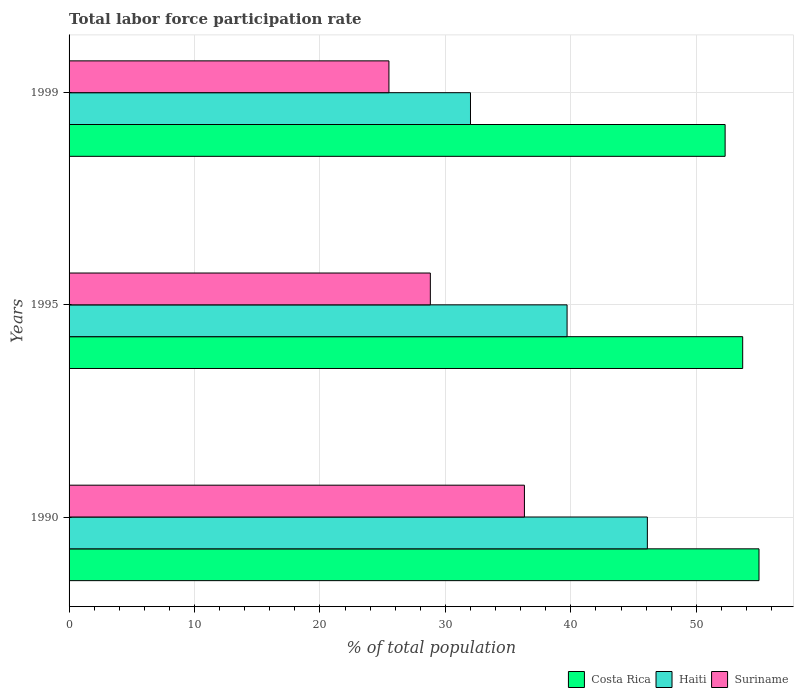How many bars are there on the 2nd tick from the top?
Make the answer very short. 3. In how many cases, is the number of bars for a given year not equal to the number of legend labels?
Your answer should be very brief. 0. What is the total labor force participation rate in Suriname in 1995?
Make the answer very short. 28.8. Across all years, what is the maximum total labor force participation rate in Costa Rica?
Your answer should be very brief. 55. In which year was the total labor force participation rate in Suriname minimum?
Ensure brevity in your answer.  1999. What is the total total labor force participation rate in Haiti in the graph?
Provide a succinct answer. 117.8. What is the difference between the total labor force participation rate in Suriname in 1990 and that in 1995?
Keep it short and to the point. 7.5. What is the difference between the total labor force participation rate in Haiti in 1990 and the total labor force participation rate in Suriname in 1995?
Your answer should be very brief. 17.3. What is the average total labor force participation rate in Haiti per year?
Offer a terse response. 39.27. In the year 1995, what is the difference between the total labor force participation rate in Haiti and total labor force participation rate in Costa Rica?
Provide a short and direct response. -14. What is the ratio of the total labor force participation rate in Haiti in 1990 to that in 1999?
Offer a terse response. 1.44. Is the difference between the total labor force participation rate in Haiti in 1990 and 1999 greater than the difference between the total labor force participation rate in Costa Rica in 1990 and 1999?
Ensure brevity in your answer.  Yes. What is the difference between the highest and the second highest total labor force participation rate in Costa Rica?
Provide a short and direct response. 1.3. What is the difference between the highest and the lowest total labor force participation rate in Haiti?
Offer a very short reply. 14.1. In how many years, is the total labor force participation rate in Suriname greater than the average total labor force participation rate in Suriname taken over all years?
Ensure brevity in your answer.  1. Is the sum of the total labor force participation rate in Costa Rica in 1990 and 1999 greater than the maximum total labor force participation rate in Suriname across all years?
Offer a terse response. Yes. What does the 1st bar from the top in 1995 represents?
Give a very brief answer. Suriname. What does the 3rd bar from the bottom in 1990 represents?
Your answer should be compact. Suriname. Is it the case that in every year, the sum of the total labor force participation rate in Suriname and total labor force participation rate in Haiti is greater than the total labor force participation rate in Costa Rica?
Ensure brevity in your answer.  Yes. How many bars are there?
Your answer should be compact. 9. Are all the bars in the graph horizontal?
Give a very brief answer. Yes. What is the difference between two consecutive major ticks on the X-axis?
Your answer should be very brief. 10. Are the values on the major ticks of X-axis written in scientific E-notation?
Provide a short and direct response. No. Does the graph contain any zero values?
Provide a succinct answer. No. Does the graph contain grids?
Make the answer very short. Yes. Where does the legend appear in the graph?
Ensure brevity in your answer.  Bottom right. How many legend labels are there?
Offer a terse response. 3. How are the legend labels stacked?
Give a very brief answer. Horizontal. What is the title of the graph?
Provide a succinct answer. Total labor force participation rate. Does "Canada" appear as one of the legend labels in the graph?
Give a very brief answer. No. What is the label or title of the X-axis?
Your answer should be compact. % of total population. What is the label or title of the Y-axis?
Make the answer very short. Years. What is the % of total population of Haiti in 1990?
Offer a terse response. 46.1. What is the % of total population in Suriname in 1990?
Ensure brevity in your answer.  36.3. What is the % of total population in Costa Rica in 1995?
Your answer should be compact. 53.7. What is the % of total population in Haiti in 1995?
Your response must be concise. 39.7. What is the % of total population in Suriname in 1995?
Your answer should be compact. 28.8. What is the % of total population in Costa Rica in 1999?
Give a very brief answer. 52.3. What is the % of total population in Haiti in 1999?
Offer a terse response. 32. Across all years, what is the maximum % of total population in Haiti?
Your answer should be compact. 46.1. Across all years, what is the maximum % of total population of Suriname?
Your answer should be compact. 36.3. Across all years, what is the minimum % of total population of Costa Rica?
Your answer should be very brief. 52.3. Across all years, what is the minimum % of total population of Haiti?
Your answer should be very brief. 32. Across all years, what is the minimum % of total population of Suriname?
Your answer should be compact. 25.5. What is the total % of total population in Costa Rica in the graph?
Make the answer very short. 161. What is the total % of total population in Haiti in the graph?
Give a very brief answer. 117.8. What is the total % of total population of Suriname in the graph?
Offer a very short reply. 90.6. What is the difference between the % of total population in Costa Rica in 1990 and that in 1995?
Your answer should be very brief. 1.3. What is the difference between the % of total population of Haiti in 1990 and that in 1999?
Give a very brief answer. 14.1. What is the difference between the % of total population of Costa Rica in 1990 and the % of total population of Haiti in 1995?
Your answer should be compact. 15.3. What is the difference between the % of total population of Costa Rica in 1990 and the % of total population of Suriname in 1995?
Provide a succinct answer. 26.2. What is the difference between the % of total population of Haiti in 1990 and the % of total population of Suriname in 1995?
Ensure brevity in your answer.  17.3. What is the difference between the % of total population of Costa Rica in 1990 and the % of total population of Haiti in 1999?
Offer a very short reply. 23. What is the difference between the % of total population in Costa Rica in 1990 and the % of total population in Suriname in 1999?
Your answer should be very brief. 29.5. What is the difference between the % of total population in Haiti in 1990 and the % of total population in Suriname in 1999?
Provide a short and direct response. 20.6. What is the difference between the % of total population in Costa Rica in 1995 and the % of total population in Haiti in 1999?
Give a very brief answer. 21.7. What is the difference between the % of total population of Costa Rica in 1995 and the % of total population of Suriname in 1999?
Offer a terse response. 28.2. What is the difference between the % of total population of Haiti in 1995 and the % of total population of Suriname in 1999?
Provide a short and direct response. 14.2. What is the average % of total population of Costa Rica per year?
Ensure brevity in your answer.  53.67. What is the average % of total population in Haiti per year?
Your response must be concise. 39.27. What is the average % of total population of Suriname per year?
Offer a very short reply. 30.2. In the year 1990, what is the difference between the % of total population of Costa Rica and % of total population of Suriname?
Offer a terse response. 18.7. In the year 1995, what is the difference between the % of total population of Costa Rica and % of total population of Haiti?
Provide a succinct answer. 14. In the year 1995, what is the difference between the % of total population of Costa Rica and % of total population of Suriname?
Your response must be concise. 24.9. In the year 1995, what is the difference between the % of total population in Haiti and % of total population in Suriname?
Give a very brief answer. 10.9. In the year 1999, what is the difference between the % of total population of Costa Rica and % of total population of Haiti?
Make the answer very short. 20.3. In the year 1999, what is the difference between the % of total population of Costa Rica and % of total population of Suriname?
Ensure brevity in your answer.  26.8. In the year 1999, what is the difference between the % of total population in Haiti and % of total population in Suriname?
Ensure brevity in your answer.  6.5. What is the ratio of the % of total population in Costa Rica in 1990 to that in 1995?
Your answer should be very brief. 1.02. What is the ratio of the % of total population in Haiti in 1990 to that in 1995?
Your response must be concise. 1.16. What is the ratio of the % of total population in Suriname in 1990 to that in 1995?
Provide a short and direct response. 1.26. What is the ratio of the % of total population in Costa Rica in 1990 to that in 1999?
Ensure brevity in your answer.  1.05. What is the ratio of the % of total population of Haiti in 1990 to that in 1999?
Make the answer very short. 1.44. What is the ratio of the % of total population of Suriname in 1990 to that in 1999?
Your answer should be compact. 1.42. What is the ratio of the % of total population in Costa Rica in 1995 to that in 1999?
Your response must be concise. 1.03. What is the ratio of the % of total population in Haiti in 1995 to that in 1999?
Your answer should be compact. 1.24. What is the ratio of the % of total population in Suriname in 1995 to that in 1999?
Ensure brevity in your answer.  1.13. What is the difference between the highest and the second highest % of total population of Costa Rica?
Your response must be concise. 1.3. What is the difference between the highest and the second highest % of total population in Haiti?
Offer a very short reply. 6.4. What is the difference between the highest and the second highest % of total population in Suriname?
Your response must be concise. 7.5. What is the difference between the highest and the lowest % of total population in Haiti?
Provide a succinct answer. 14.1. What is the difference between the highest and the lowest % of total population of Suriname?
Offer a very short reply. 10.8. 